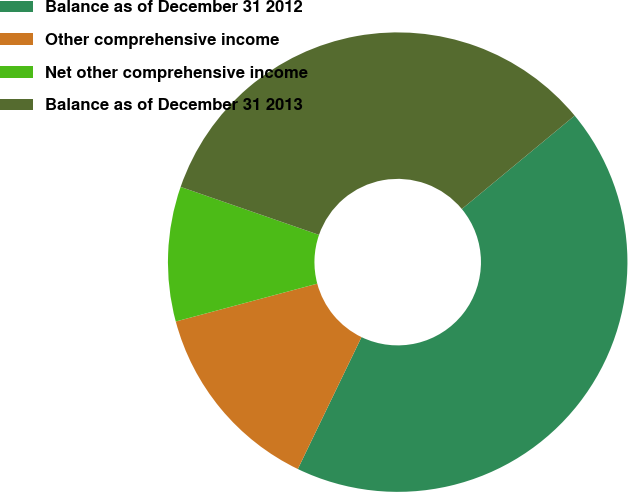Convert chart to OTSL. <chart><loc_0><loc_0><loc_500><loc_500><pie_chart><fcel>Balance as of December 31 2012<fcel>Other comprehensive income<fcel>Net other comprehensive income<fcel>Balance as of December 31 2013<nl><fcel>43.16%<fcel>13.68%<fcel>9.47%<fcel>33.68%<nl></chart> 